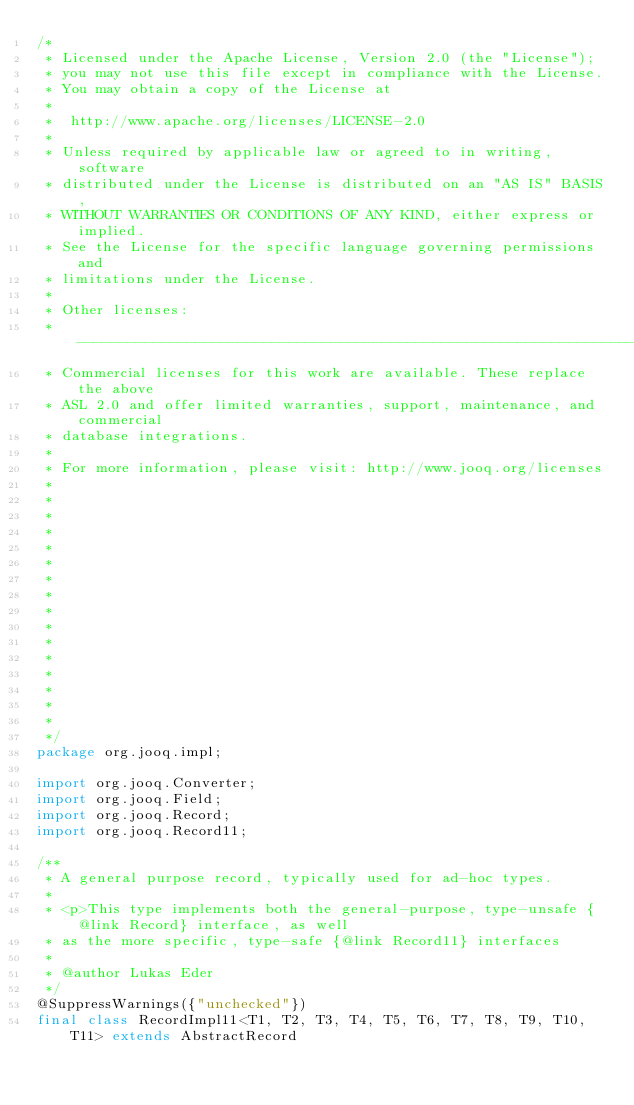Convert code to text. <code><loc_0><loc_0><loc_500><loc_500><_Java_>/* 
 * Licensed under the Apache License, Version 2.0 (the "License");
 * you may not use this file except in compliance with the License.
 * You may obtain a copy of the License at
 *
 *  http://www.apache.org/licenses/LICENSE-2.0
 *
 * Unless required by applicable law or agreed to in writing, software
 * distributed under the License is distributed on an "AS IS" BASIS,
 * WITHOUT WARRANTIES OR CONDITIONS OF ANY KIND, either express or implied.
 * See the License for the specific language governing permissions and
 * limitations under the License.
 *
 * Other licenses:
 * -----------------------------------------------------------------------------
 * Commercial licenses for this work are available. These replace the above
 * ASL 2.0 and offer limited warranties, support, maintenance, and commercial
 * database integrations.
 *
 * For more information, please visit: http://www.jooq.org/licenses
 *
 *
 *
 *
 *
 *
 *
 *
 *
 *
 *
 *
 *
 *
 *
 *
 */
package org.jooq.impl;

import org.jooq.Converter;
import org.jooq.Field;
import org.jooq.Record;
import org.jooq.Record11;

/**
 * A general purpose record, typically used for ad-hoc types.
 *
 * <p>This type implements both the general-purpose, type-unsafe {@link Record} interface, as well
 * as the more specific, type-safe {@link Record11} interfaces
 *
 * @author Lukas Eder
 */
@SuppressWarnings({"unchecked"})
final class RecordImpl11<T1, T2, T3, T4, T5, T6, T7, T8, T9, T10, T11> extends AbstractRecord</code> 